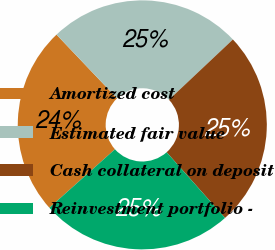<chart> <loc_0><loc_0><loc_500><loc_500><pie_chart><fcel>Amortized cost<fcel>Estimated fair value<fcel>Cash collateral on deposit<fcel>Reinvestment portfolio -<nl><fcel>24.5%<fcel>25.07%<fcel>25.46%<fcel>24.97%<nl></chart> 